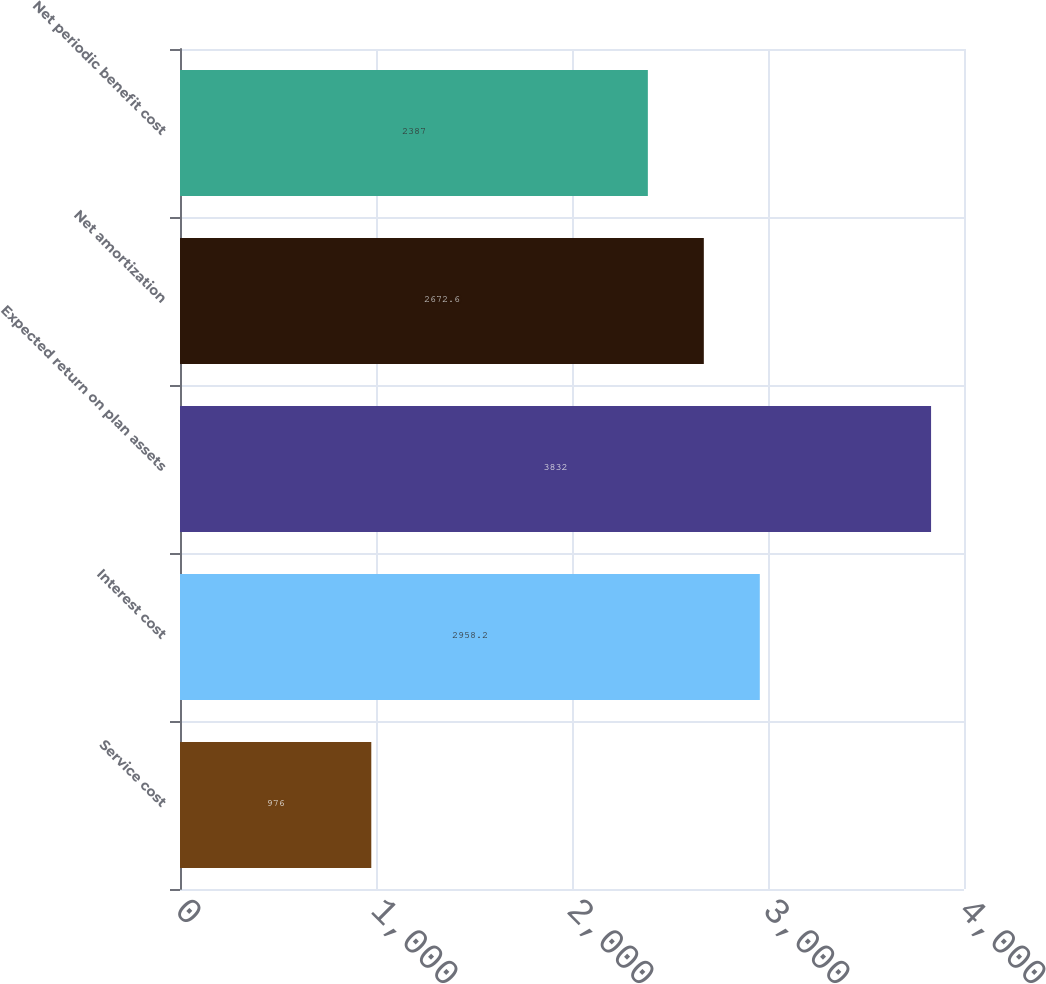Convert chart. <chart><loc_0><loc_0><loc_500><loc_500><bar_chart><fcel>Service cost<fcel>Interest cost<fcel>Expected return on plan assets<fcel>Net amortization<fcel>Net periodic benefit cost<nl><fcel>976<fcel>2958.2<fcel>3832<fcel>2672.6<fcel>2387<nl></chart> 